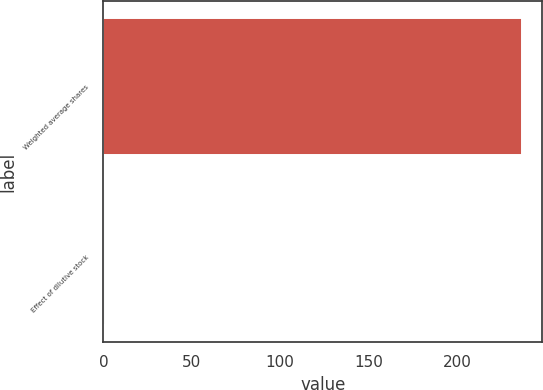<chart> <loc_0><loc_0><loc_500><loc_500><bar_chart><fcel>Weighted average shares<fcel>Effect of dilutive stock<nl><fcel>236.5<fcel>0.8<nl></chart> 